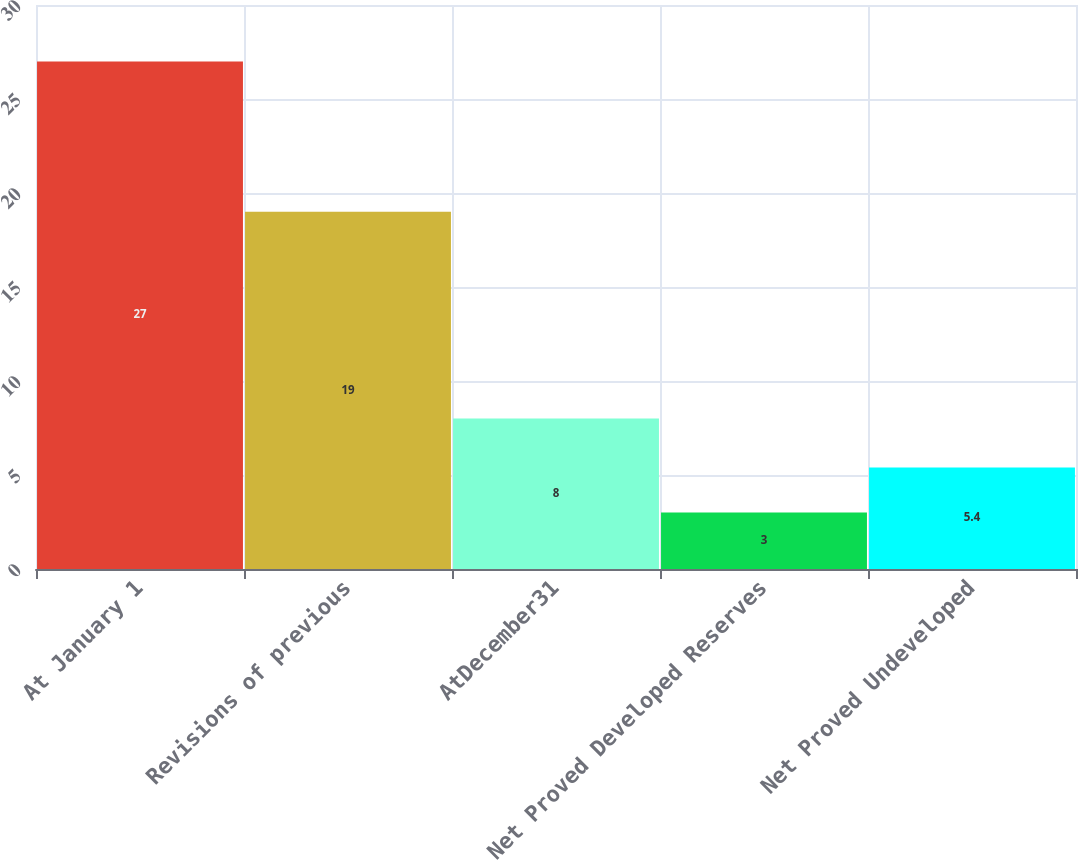Convert chart to OTSL. <chart><loc_0><loc_0><loc_500><loc_500><bar_chart><fcel>At January 1<fcel>Revisions of previous<fcel>AtDecember31<fcel>Net Proved Developed Reserves<fcel>Net Proved Undeveloped<nl><fcel>27<fcel>19<fcel>8<fcel>3<fcel>5.4<nl></chart> 